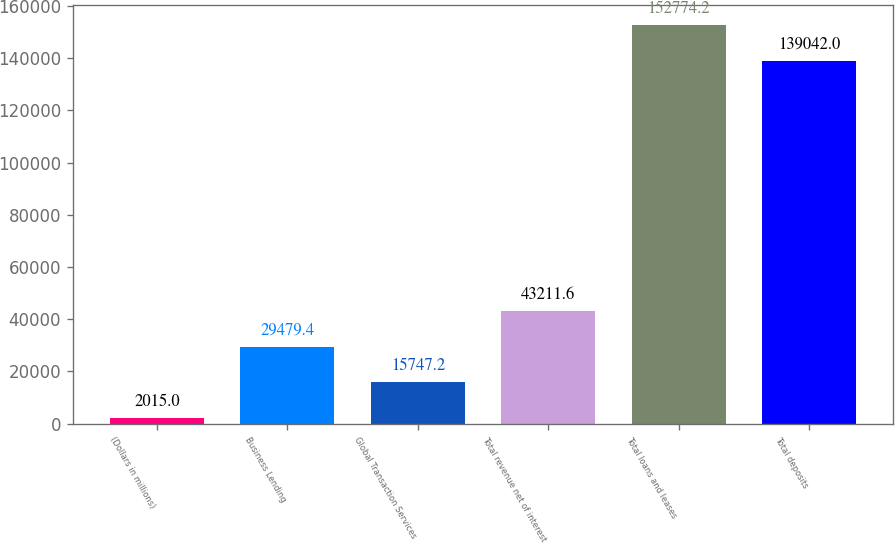Convert chart to OTSL. <chart><loc_0><loc_0><loc_500><loc_500><bar_chart><fcel>(Dollars in millions)<fcel>Business Lending<fcel>Global Transaction Services<fcel>Total revenue net of interest<fcel>Total loans and leases<fcel>Total deposits<nl><fcel>2015<fcel>29479.4<fcel>15747.2<fcel>43211.6<fcel>152774<fcel>139042<nl></chart> 